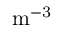<formula> <loc_0><loc_0><loc_500><loc_500>m ^ { - 3 }</formula> 